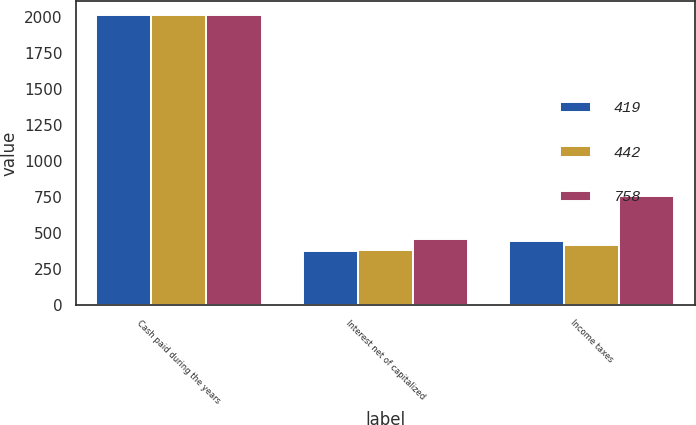Convert chart to OTSL. <chart><loc_0><loc_0><loc_500><loc_500><stacked_bar_chart><ecel><fcel>Cash paid during the years<fcel>Interest net of capitalized<fcel>Income taxes<nl><fcel>419<fcel>2016<fcel>375<fcel>442<nl><fcel>442<fcel>2015<fcel>384<fcel>419<nl><fcel>758<fcel>2014<fcel>461<fcel>758<nl></chart> 